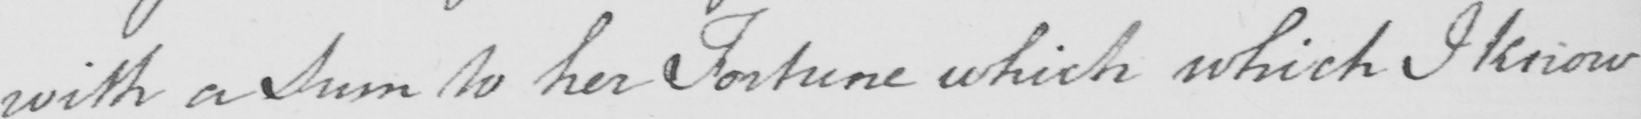Please provide the text content of this handwritten line. with a Sum to her Fortune which which I know 